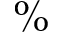Convert formula to latex. <formula><loc_0><loc_0><loc_500><loc_500>\%</formula> 